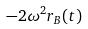<formula> <loc_0><loc_0><loc_500><loc_500>- 2 \omega ^ { 2 } r _ { B } ( t )</formula> 